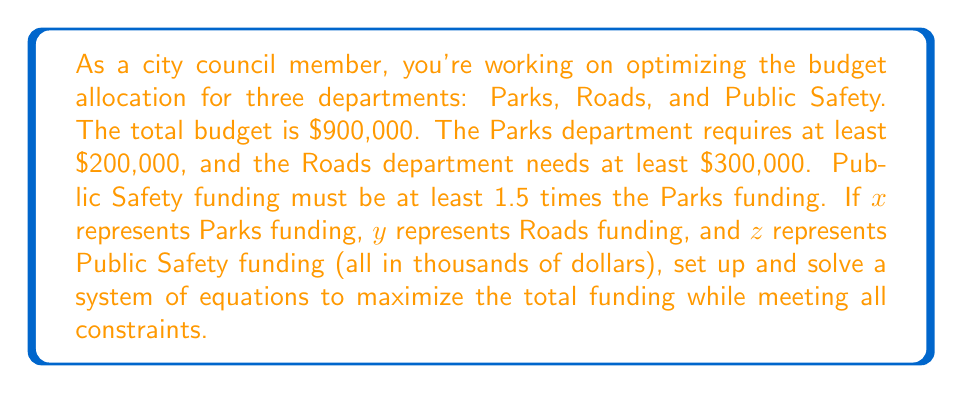Help me with this question. Let's approach this step-by-step:

1) First, we need to set up our constraints:

   Total budget: $x + y + z = 900$
   Parks minimum: $x \geq 200$
   Roads minimum: $y \geq 300$
   Public Safety in relation to Parks: $z \geq 1.5x$

2) We want to maximize the total funding, which is already $900,000. So, we need to find the minimum values that satisfy all constraints.

3) We know $x \geq 200$ and $y \geq 300$. Let's start with these minimum values:
   
   $x = 200$
   $y = 300$

4) For Public Safety, we need $z \geq 1.5x = 1.5(200) = 300$

5) Now, let's check if these values satisfy our total budget constraint:

   $200 + 300 + 300 = 800$

   This is less than our total budget of $900, so we can increase z.

6) The maximum value for z would be:

   $z = 900 - 200 - 300 = 400$

7) Let's verify if this satisfies all constraints:

   $x + y + z = 200 + 300 + 400 = 900$ (Total budget constraint met)
   $x = 200 \geq 200$ (Parks minimum met)
   $y = 300 \geq 300$ (Roads minimum met)
   $z = 400 > 1.5(200) = 300$ (Public Safety in relation to Parks met)

Therefore, the optimal allocation is:
Parks (x) = $200,000
Roads (y) = $300,000
Public Safety (z) = $400,000
Answer: Parks: $200,000, Roads: $300,000, Public Safety: $400,000 